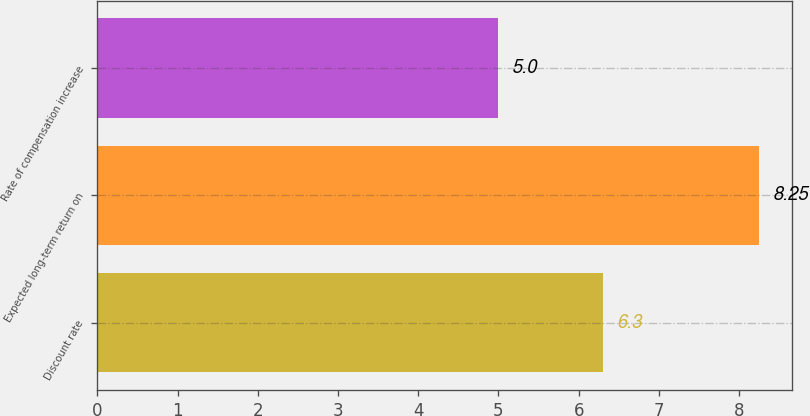<chart> <loc_0><loc_0><loc_500><loc_500><bar_chart><fcel>Discount rate<fcel>Expected long-term return on<fcel>Rate of compensation increase<nl><fcel>6.3<fcel>8.25<fcel>5<nl></chart> 